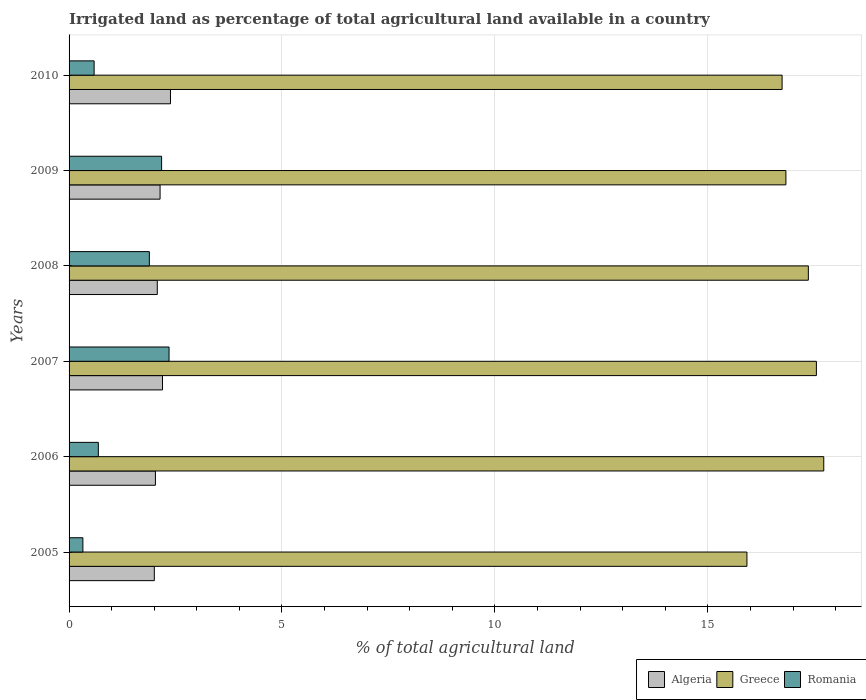How many different coloured bars are there?
Ensure brevity in your answer.  3. Are the number of bars per tick equal to the number of legend labels?
Your answer should be compact. Yes. Are the number of bars on each tick of the Y-axis equal?
Keep it short and to the point. Yes. What is the label of the 2nd group of bars from the top?
Provide a short and direct response. 2009. What is the percentage of irrigated land in Algeria in 2006?
Provide a succinct answer. 2.03. Across all years, what is the maximum percentage of irrigated land in Algeria?
Provide a short and direct response. 2.38. Across all years, what is the minimum percentage of irrigated land in Greece?
Provide a succinct answer. 15.92. In which year was the percentage of irrigated land in Algeria maximum?
Offer a terse response. 2010. What is the total percentage of irrigated land in Greece in the graph?
Your answer should be very brief. 102.13. What is the difference between the percentage of irrigated land in Romania in 2006 and that in 2007?
Provide a succinct answer. -1.66. What is the difference between the percentage of irrigated land in Romania in 2006 and the percentage of irrigated land in Greece in 2005?
Your answer should be compact. -15.23. What is the average percentage of irrigated land in Algeria per year?
Your answer should be compact. 2.14. In the year 2007, what is the difference between the percentage of irrigated land in Algeria and percentage of irrigated land in Romania?
Keep it short and to the point. -0.15. What is the ratio of the percentage of irrigated land in Algeria in 2007 to that in 2010?
Provide a succinct answer. 0.92. Is the percentage of irrigated land in Algeria in 2006 less than that in 2010?
Your answer should be compact. Yes. What is the difference between the highest and the second highest percentage of irrigated land in Romania?
Your answer should be compact. 0.17. What is the difference between the highest and the lowest percentage of irrigated land in Romania?
Ensure brevity in your answer.  2.02. In how many years, is the percentage of irrigated land in Algeria greater than the average percentage of irrigated land in Algeria taken over all years?
Your response must be concise. 3. Is the sum of the percentage of irrigated land in Algeria in 2007 and 2009 greater than the maximum percentage of irrigated land in Romania across all years?
Your answer should be very brief. Yes. What does the 3rd bar from the top in 2006 represents?
Keep it short and to the point. Algeria. What does the 3rd bar from the bottom in 2005 represents?
Your answer should be very brief. Romania. How many bars are there?
Ensure brevity in your answer.  18. Are all the bars in the graph horizontal?
Ensure brevity in your answer.  Yes. What is the difference between two consecutive major ticks on the X-axis?
Offer a very short reply. 5. Does the graph contain any zero values?
Keep it short and to the point. No. How many legend labels are there?
Keep it short and to the point. 3. How are the legend labels stacked?
Provide a succinct answer. Horizontal. What is the title of the graph?
Your answer should be compact. Irrigated land as percentage of total agricultural land available in a country. What is the label or title of the X-axis?
Provide a succinct answer. % of total agricultural land. What is the label or title of the Y-axis?
Provide a short and direct response. Years. What is the % of total agricultural land of Algeria in 2005?
Your response must be concise. 2. What is the % of total agricultural land of Greece in 2005?
Offer a terse response. 15.92. What is the % of total agricultural land of Romania in 2005?
Your response must be concise. 0.32. What is the % of total agricultural land in Algeria in 2006?
Give a very brief answer. 2.03. What is the % of total agricultural land in Greece in 2006?
Provide a succinct answer. 17.72. What is the % of total agricultural land of Romania in 2006?
Your response must be concise. 0.69. What is the % of total agricultural land in Algeria in 2007?
Offer a terse response. 2.19. What is the % of total agricultural land in Greece in 2007?
Provide a succinct answer. 17.55. What is the % of total agricultural land in Romania in 2007?
Provide a short and direct response. 2.35. What is the % of total agricultural land in Algeria in 2008?
Your answer should be very brief. 2.07. What is the % of total agricultural land in Greece in 2008?
Make the answer very short. 17.36. What is the % of total agricultural land in Romania in 2008?
Give a very brief answer. 1.88. What is the % of total agricultural land of Algeria in 2009?
Offer a very short reply. 2.14. What is the % of total agricultural land of Greece in 2009?
Your answer should be compact. 16.83. What is the % of total agricultural land in Romania in 2009?
Provide a succinct answer. 2.17. What is the % of total agricultural land in Algeria in 2010?
Your answer should be very brief. 2.38. What is the % of total agricultural land in Greece in 2010?
Keep it short and to the point. 16.74. What is the % of total agricultural land in Romania in 2010?
Offer a very short reply. 0.59. Across all years, what is the maximum % of total agricultural land in Algeria?
Your answer should be compact. 2.38. Across all years, what is the maximum % of total agricultural land of Greece?
Provide a succinct answer. 17.72. Across all years, what is the maximum % of total agricultural land in Romania?
Give a very brief answer. 2.35. Across all years, what is the minimum % of total agricultural land of Algeria?
Offer a terse response. 2. Across all years, what is the minimum % of total agricultural land of Greece?
Provide a succinct answer. 15.92. Across all years, what is the minimum % of total agricultural land in Romania?
Your answer should be very brief. 0.32. What is the total % of total agricultural land in Algeria in the graph?
Offer a very short reply. 12.81. What is the total % of total agricultural land of Greece in the graph?
Your answer should be very brief. 102.13. What is the total % of total agricultural land of Romania in the graph?
Your answer should be compact. 8.01. What is the difference between the % of total agricultural land of Algeria in 2005 and that in 2006?
Provide a succinct answer. -0.03. What is the difference between the % of total agricultural land of Greece in 2005 and that in 2006?
Ensure brevity in your answer.  -1.8. What is the difference between the % of total agricultural land of Romania in 2005 and that in 2006?
Ensure brevity in your answer.  -0.36. What is the difference between the % of total agricultural land in Algeria in 2005 and that in 2007?
Provide a succinct answer. -0.19. What is the difference between the % of total agricultural land of Greece in 2005 and that in 2007?
Provide a short and direct response. -1.63. What is the difference between the % of total agricultural land in Romania in 2005 and that in 2007?
Give a very brief answer. -2.02. What is the difference between the % of total agricultural land in Algeria in 2005 and that in 2008?
Offer a terse response. -0.07. What is the difference between the % of total agricultural land of Greece in 2005 and that in 2008?
Your answer should be compact. -1.44. What is the difference between the % of total agricultural land in Romania in 2005 and that in 2008?
Offer a very short reply. -1.56. What is the difference between the % of total agricultural land in Algeria in 2005 and that in 2009?
Offer a terse response. -0.14. What is the difference between the % of total agricultural land of Greece in 2005 and that in 2009?
Ensure brevity in your answer.  -0.92. What is the difference between the % of total agricultural land in Romania in 2005 and that in 2009?
Provide a succinct answer. -1.85. What is the difference between the % of total agricultural land of Algeria in 2005 and that in 2010?
Provide a short and direct response. -0.38. What is the difference between the % of total agricultural land in Greece in 2005 and that in 2010?
Make the answer very short. -0.83. What is the difference between the % of total agricultural land in Romania in 2005 and that in 2010?
Your response must be concise. -0.26. What is the difference between the % of total agricultural land in Algeria in 2006 and that in 2007?
Make the answer very short. -0.17. What is the difference between the % of total agricultural land in Greece in 2006 and that in 2007?
Keep it short and to the point. 0.17. What is the difference between the % of total agricultural land in Romania in 2006 and that in 2007?
Offer a very short reply. -1.66. What is the difference between the % of total agricultural land of Algeria in 2006 and that in 2008?
Give a very brief answer. -0.04. What is the difference between the % of total agricultural land in Greece in 2006 and that in 2008?
Provide a succinct answer. 0.36. What is the difference between the % of total agricultural land in Romania in 2006 and that in 2008?
Give a very brief answer. -1.2. What is the difference between the % of total agricultural land of Algeria in 2006 and that in 2009?
Offer a terse response. -0.11. What is the difference between the % of total agricultural land of Greece in 2006 and that in 2009?
Your response must be concise. 0.89. What is the difference between the % of total agricultural land in Romania in 2006 and that in 2009?
Ensure brevity in your answer.  -1.49. What is the difference between the % of total agricultural land of Algeria in 2006 and that in 2010?
Provide a succinct answer. -0.35. What is the difference between the % of total agricultural land of Greece in 2006 and that in 2010?
Your answer should be compact. 0.98. What is the difference between the % of total agricultural land in Romania in 2006 and that in 2010?
Make the answer very short. 0.1. What is the difference between the % of total agricultural land of Algeria in 2007 and that in 2008?
Ensure brevity in your answer.  0.12. What is the difference between the % of total agricultural land in Greece in 2007 and that in 2008?
Ensure brevity in your answer.  0.19. What is the difference between the % of total agricultural land of Romania in 2007 and that in 2008?
Your response must be concise. 0.46. What is the difference between the % of total agricultural land in Algeria in 2007 and that in 2009?
Offer a very short reply. 0.06. What is the difference between the % of total agricultural land of Greece in 2007 and that in 2009?
Keep it short and to the point. 0.72. What is the difference between the % of total agricultural land of Romania in 2007 and that in 2009?
Keep it short and to the point. 0.17. What is the difference between the % of total agricultural land in Algeria in 2007 and that in 2010?
Make the answer very short. -0.19. What is the difference between the % of total agricultural land of Greece in 2007 and that in 2010?
Your answer should be compact. 0.81. What is the difference between the % of total agricultural land in Romania in 2007 and that in 2010?
Your answer should be very brief. 1.76. What is the difference between the % of total agricultural land in Algeria in 2008 and that in 2009?
Your answer should be compact. -0.07. What is the difference between the % of total agricultural land in Greece in 2008 and that in 2009?
Provide a succinct answer. 0.53. What is the difference between the % of total agricultural land in Romania in 2008 and that in 2009?
Your response must be concise. -0.29. What is the difference between the % of total agricultural land of Algeria in 2008 and that in 2010?
Provide a short and direct response. -0.31. What is the difference between the % of total agricultural land of Greece in 2008 and that in 2010?
Provide a short and direct response. 0.62. What is the difference between the % of total agricultural land in Romania in 2008 and that in 2010?
Your response must be concise. 1.3. What is the difference between the % of total agricultural land in Algeria in 2009 and that in 2010?
Offer a terse response. -0.24. What is the difference between the % of total agricultural land of Greece in 2009 and that in 2010?
Ensure brevity in your answer.  0.09. What is the difference between the % of total agricultural land of Romania in 2009 and that in 2010?
Give a very brief answer. 1.58. What is the difference between the % of total agricultural land of Algeria in 2005 and the % of total agricultural land of Greece in 2006?
Your answer should be very brief. -15.72. What is the difference between the % of total agricultural land in Algeria in 2005 and the % of total agricultural land in Romania in 2006?
Provide a succinct answer. 1.31. What is the difference between the % of total agricultural land in Greece in 2005 and the % of total agricultural land in Romania in 2006?
Ensure brevity in your answer.  15.23. What is the difference between the % of total agricultural land of Algeria in 2005 and the % of total agricultural land of Greece in 2007?
Ensure brevity in your answer.  -15.55. What is the difference between the % of total agricultural land in Algeria in 2005 and the % of total agricultural land in Romania in 2007?
Your answer should be very brief. -0.35. What is the difference between the % of total agricultural land in Greece in 2005 and the % of total agricultural land in Romania in 2007?
Ensure brevity in your answer.  13.57. What is the difference between the % of total agricultural land in Algeria in 2005 and the % of total agricultural land in Greece in 2008?
Offer a terse response. -15.36. What is the difference between the % of total agricultural land in Algeria in 2005 and the % of total agricultural land in Romania in 2008?
Give a very brief answer. 0.12. What is the difference between the % of total agricultural land of Greece in 2005 and the % of total agricultural land of Romania in 2008?
Your answer should be compact. 14.03. What is the difference between the % of total agricultural land in Algeria in 2005 and the % of total agricultural land in Greece in 2009?
Provide a succinct answer. -14.83. What is the difference between the % of total agricultural land in Algeria in 2005 and the % of total agricultural land in Romania in 2009?
Ensure brevity in your answer.  -0.17. What is the difference between the % of total agricultural land in Greece in 2005 and the % of total agricultural land in Romania in 2009?
Your answer should be very brief. 13.75. What is the difference between the % of total agricultural land of Algeria in 2005 and the % of total agricultural land of Greece in 2010?
Provide a short and direct response. -14.74. What is the difference between the % of total agricultural land in Algeria in 2005 and the % of total agricultural land in Romania in 2010?
Your answer should be compact. 1.41. What is the difference between the % of total agricultural land of Greece in 2005 and the % of total agricultural land of Romania in 2010?
Your response must be concise. 15.33. What is the difference between the % of total agricultural land of Algeria in 2006 and the % of total agricultural land of Greece in 2007?
Provide a short and direct response. -15.52. What is the difference between the % of total agricultural land in Algeria in 2006 and the % of total agricultural land in Romania in 2007?
Offer a very short reply. -0.32. What is the difference between the % of total agricultural land of Greece in 2006 and the % of total agricultural land of Romania in 2007?
Give a very brief answer. 15.37. What is the difference between the % of total agricultural land in Algeria in 2006 and the % of total agricultural land in Greece in 2008?
Offer a very short reply. -15.33. What is the difference between the % of total agricultural land in Algeria in 2006 and the % of total agricultural land in Romania in 2008?
Offer a terse response. 0.14. What is the difference between the % of total agricultural land in Greece in 2006 and the % of total agricultural land in Romania in 2008?
Make the answer very short. 15.84. What is the difference between the % of total agricultural land in Algeria in 2006 and the % of total agricultural land in Greece in 2009?
Offer a terse response. -14.81. What is the difference between the % of total agricultural land of Algeria in 2006 and the % of total agricultural land of Romania in 2009?
Offer a very short reply. -0.15. What is the difference between the % of total agricultural land of Greece in 2006 and the % of total agricultural land of Romania in 2009?
Offer a very short reply. 15.55. What is the difference between the % of total agricultural land in Algeria in 2006 and the % of total agricultural land in Greece in 2010?
Keep it short and to the point. -14.72. What is the difference between the % of total agricultural land of Algeria in 2006 and the % of total agricultural land of Romania in 2010?
Your response must be concise. 1.44. What is the difference between the % of total agricultural land in Greece in 2006 and the % of total agricultural land in Romania in 2010?
Keep it short and to the point. 17.13. What is the difference between the % of total agricultural land in Algeria in 2007 and the % of total agricultural land in Greece in 2008?
Offer a very short reply. -15.17. What is the difference between the % of total agricultural land in Algeria in 2007 and the % of total agricultural land in Romania in 2008?
Make the answer very short. 0.31. What is the difference between the % of total agricultural land of Greece in 2007 and the % of total agricultural land of Romania in 2008?
Provide a short and direct response. 15.66. What is the difference between the % of total agricultural land in Algeria in 2007 and the % of total agricultural land in Greece in 2009?
Keep it short and to the point. -14.64. What is the difference between the % of total agricultural land of Algeria in 2007 and the % of total agricultural land of Romania in 2009?
Provide a succinct answer. 0.02. What is the difference between the % of total agricultural land of Greece in 2007 and the % of total agricultural land of Romania in 2009?
Your response must be concise. 15.38. What is the difference between the % of total agricultural land of Algeria in 2007 and the % of total agricultural land of Greece in 2010?
Keep it short and to the point. -14.55. What is the difference between the % of total agricultural land in Algeria in 2007 and the % of total agricultural land in Romania in 2010?
Your response must be concise. 1.61. What is the difference between the % of total agricultural land in Greece in 2007 and the % of total agricultural land in Romania in 2010?
Offer a terse response. 16.96. What is the difference between the % of total agricultural land of Algeria in 2008 and the % of total agricultural land of Greece in 2009?
Provide a short and direct response. -14.76. What is the difference between the % of total agricultural land in Algeria in 2008 and the % of total agricultural land in Romania in 2009?
Ensure brevity in your answer.  -0.1. What is the difference between the % of total agricultural land of Greece in 2008 and the % of total agricultural land of Romania in 2009?
Offer a terse response. 15.19. What is the difference between the % of total agricultural land in Algeria in 2008 and the % of total agricultural land in Greece in 2010?
Your response must be concise. -14.67. What is the difference between the % of total agricultural land in Algeria in 2008 and the % of total agricultural land in Romania in 2010?
Keep it short and to the point. 1.48. What is the difference between the % of total agricultural land of Greece in 2008 and the % of total agricultural land of Romania in 2010?
Your response must be concise. 16.77. What is the difference between the % of total agricultural land of Algeria in 2009 and the % of total agricultural land of Greece in 2010?
Make the answer very short. -14.61. What is the difference between the % of total agricultural land in Algeria in 2009 and the % of total agricultural land in Romania in 2010?
Provide a short and direct response. 1.55. What is the difference between the % of total agricultural land in Greece in 2009 and the % of total agricultural land in Romania in 2010?
Ensure brevity in your answer.  16.25. What is the average % of total agricultural land of Algeria per year?
Keep it short and to the point. 2.14. What is the average % of total agricultural land of Greece per year?
Provide a succinct answer. 17.02. What is the average % of total agricultural land of Romania per year?
Offer a terse response. 1.33. In the year 2005, what is the difference between the % of total agricultural land in Algeria and % of total agricultural land in Greece?
Your answer should be very brief. -13.92. In the year 2005, what is the difference between the % of total agricultural land in Algeria and % of total agricultural land in Romania?
Your response must be concise. 1.68. In the year 2005, what is the difference between the % of total agricultural land in Greece and % of total agricultural land in Romania?
Offer a very short reply. 15.59. In the year 2006, what is the difference between the % of total agricultural land of Algeria and % of total agricultural land of Greece?
Provide a succinct answer. -15.69. In the year 2006, what is the difference between the % of total agricultural land in Algeria and % of total agricultural land in Romania?
Provide a short and direct response. 1.34. In the year 2006, what is the difference between the % of total agricultural land of Greece and % of total agricultural land of Romania?
Offer a very short reply. 17.04. In the year 2007, what is the difference between the % of total agricultural land in Algeria and % of total agricultural land in Greece?
Offer a very short reply. -15.36. In the year 2007, what is the difference between the % of total agricultural land in Algeria and % of total agricultural land in Romania?
Offer a terse response. -0.15. In the year 2007, what is the difference between the % of total agricultural land in Greece and % of total agricultural land in Romania?
Provide a short and direct response. 15.2. In the year 2008, what is the difference between the % of total agricultural land of Algeria and % of total agricultural land of Greece?
Offer a terse response. -15.29. In the year 2008, what is the difference between the % of total agricultural land in Algeria and % of total agricultural land in Romania?
Your answer should be very brief. 0.19. In the year 2008, what is the difference between the % of total agricultural land of Greece and % of total agricultural land of Romania?
Offer a very short reply. 15.48. In the year 2009, what is the difference between the % of total agricultural land in Algeria and % of total agricultural land in Greece?
Provide a succinct answer. -14.7. In the year 2009, what is the difference between the % of total agricultural land of Algeria and % of total agricultural land of Romania?
Give a very brief answer. -0.04. In the year 2009, what is the difference between the % of total agricultural land of Greece and % of total agricultural land of Romania?
Ensure brevity in your answer.  14.66. In the year 2010, what is the difference between the % of total agricultural land of Algeria and % of total agricultural land of Greece?
Your response must be concise. -14.36. In the year 2010, what is the difference between the % of total agricultural land in Algeria and % of total agricultural land in Romania?
Your response must be concise. 1.79. In the year 2010, what is the difference between the % of total agricultural land in Greece and % of total agricultural land in Romania?
Provide a succinct answer. 16.16. What is the ratio of the % of total agricultural land in Algeria in 2005 to that in 2006?
Provide a short and direct response. 0.99. What is the ratio of the % of total agricultural land of Greece in 2005 to that in 2006?
Ensure brevity in your answer.  0.9. What is the ratio of the % of total agricultural land in Romania in 2005 to that in 2006?
Ensure brevity in your answer.  0.47. What is the ratio of the % of total agricultural land of Algeria in 2005 to that in 2007?
Your answer should be compact. 0.91. What is the ratio of the % of total agricultural land of Greece in 2005 to that in 2007?
Your answer should be very brief. 0.91. What is the ratio of the % of total agricultural land of Romania in 2005 to that in 2007?
Provide a short and direct response. 0.14. What is the ratio of the % of total agricultural land in Algeria in 2005 to that in 2008?
Provide a short and direct response. 0.97. What is the ratio of the % of total agricultural land in Greece in 2005 to that in 2008?
Provide a succinct answer. 0.92. What is the ratio of the % of total agricultural land in Romania in 2005 to that in 2008?
Ensure brevity in your answer.  0.17. What is the ratio of the % of total agricultural land in Algeria in 2005 to that in 2009?
Give a very brief answer. 0.94. What is the ratio of the % of total agricultural land in Greece in 2005 to that in 2009?
Offer a very short reply. 0.95. What is the ratio of the % of total agricultural land in Romania in 2005 to that in 2009?
Offer a very short reply. 0.15. What is the ratio of the % of total agricultural land in Algeria in 2005 to that in 2010?
Ensure brevity in your answer.  0.84. What is the ratio of the % of total agricultural land of Greece in 2005 to that in 2010?
Offer a terse response. 0.95. What is the ratio of the % of total agricultural land of Romania in 2005 to that in 2010?
Your answer should be very brief. 0.55. What is the ratio of the % of total agricultural land in Algeria in 2006 to that in 2007?
Provide a succinct answer. 0.92. What is the ratio of the % of total agricultural land in Greece in 2006 to that in 2007?
Your answer should be very brief. 1.01. What is the ratio of the % of total agricultural land of Romania in 2006 to that in 2007?
Your answer should be compact. 0.29. What is the ratio of the % of total agricultural land in Algeria in 2006 to that in 2008?
Your answer should be very brief. 0.98. What is the ratio of the % of total agricultural land in Greece in 2006 to that in 2008?
Your answer should be very brief. 1.02. What is the ratio of the % of total agricultural land of Romania in 2006 to that in 2008?
Offer a terse response. 0.36. What is the ratio of the % of total agricultural land of Algeria in 2006 to that in 2009?
Make the answer very short. 0.95. What is the ratio of the % of total agricultural land in Greece in 2006 to that in 2009?
Give a very brief answer. 1.05. What is the ratio of the % of total agricultural land in Romania in 2006 to that in 2009?
Your answer should be compact. 0.32. What is the ratio of the % of total agricultural land of Algeria in 2006 to that in 2010?
Your answer should be compact. 0.85. What is the ratio of the % of total agricultural land of Greece in 2006 to that in 2010?
Provide a short and direct response. 1.06. What is the ratio of the % of total agricultural land in Romania in 2006 to that in 2010?
Offer a terse response. 1.17. What is the ratio of the % of total agricultural land of Algeria in 2007 to that in 2008?
Give a very brief answer. 1.06. What is the ratio of the % of total agricultural land of Greece in 2007 to that in 2008?
Keep it short and to the point. 1.01. What is the ratio of the % of total agricultural land in Romania in 2007 to that in 2008?
Provide a short and direct response. 1.25. What is the ratio of the % of total agricultural land in Algeria in 2007 to that in 2009?
Ensure brevity in your answer.  1.03. What is the ratio of the % of total agricultural land of Greece in 2007 to that in 2009?
Offer a very short reply. 1.04. What is the ratio of the % of total agricultural land in Romania in 2007 to that in 2009?
Your answer should be compact. 1.08. What is the ratio of the % of total agricultural land of Algeria in 2007 to that in 2010?
Provide a short and direct response. 0.92. What is the ratio of the % of total agricultural land in Greece in 2007 to that in 2010?
Make the answer very short. 1.05. What is the ratio of the % of total agricultural land in Romania in 2007 to that in 2010?
Make the answer very short. 3.99. What is the ratio of the % of total agricultural land of Algeria in 2008 to that in 2009?
Provide a short and direct response. 0.97. What is the ratio of the % of total agricultural land in Greece in 2008 to that in 2009?
Keep it short and to the point. 1.03. What is the ratio of the % of total agricultural land in Romania in 2008 to that in 2009?
Your response must be concise. 0.87. What is the ratio of the % of total agricultural land in Algeria in 2008 to that in 2010?
Keep it short and to the point. 0.87. What is the ratio of the % of total agricultural land of Greece in 2008 to that in 2010?
Provide a succinct answer. 1.04. What is the ratio of the % of total agricultural land of Romania in 2008 to that in 2010?
Keep it short and to the point. 3.2. What is the ratio of the % of total agricultural land in Algeria in 2009 to that in 2010?
Your response must be concise. 0.9. What is the ratio of the % of total agricultural land in Greece in 2009 to that in 2010?
Provide a succinct answer. 1.01. What is the ratio of the % of total agricultural land in Romania in 2009 to that in 2010?
Your response must be concise. 3.69. What is the difference between the highest and the second highest % of total agricultural land of Algeria?
Your response must be concise. 0.19. What is the difference between the highest and the second highest % of total agricultural land in Greece?
Give a very brief answer. 0.17. What is the difference between the highest and the second highest % of total agricultural land in Romania?
Make the answer very short. 0.17. What is the difference between the highest and the lowest % of total agricultural land of Algeria?
Your response must be concise. 0.38. What is the difference between the highest and the lowest % of total agricultural land of Greece?
Ensure brevity in your answer.  1.8. What is the difference between the highest and the lowest % of total agricultural land of Romania?
Make the answer very short. 2.02. 